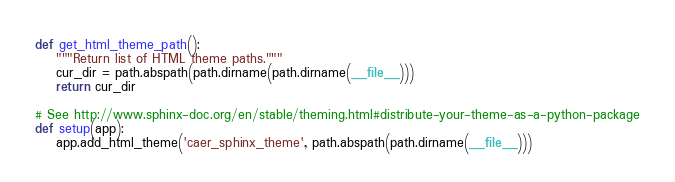<code> <loc_0><loc_0><loc_500><loc_500><_Python_>

def get_html_theme_path():
    """Return list of HTML theme paths."""
    cur_dir = path.abspath(path.dirname(path.dirname(__file__)))
    return cur_dir

# See http://www.sphinx-doc.org/en/stable/theming.html#distribute-your-theme-as-a-python-package
def setup(app):
    app.add_html_theme('caer_sphinx_theme', path.abspath(path.dirname(__file__)))
</code> 